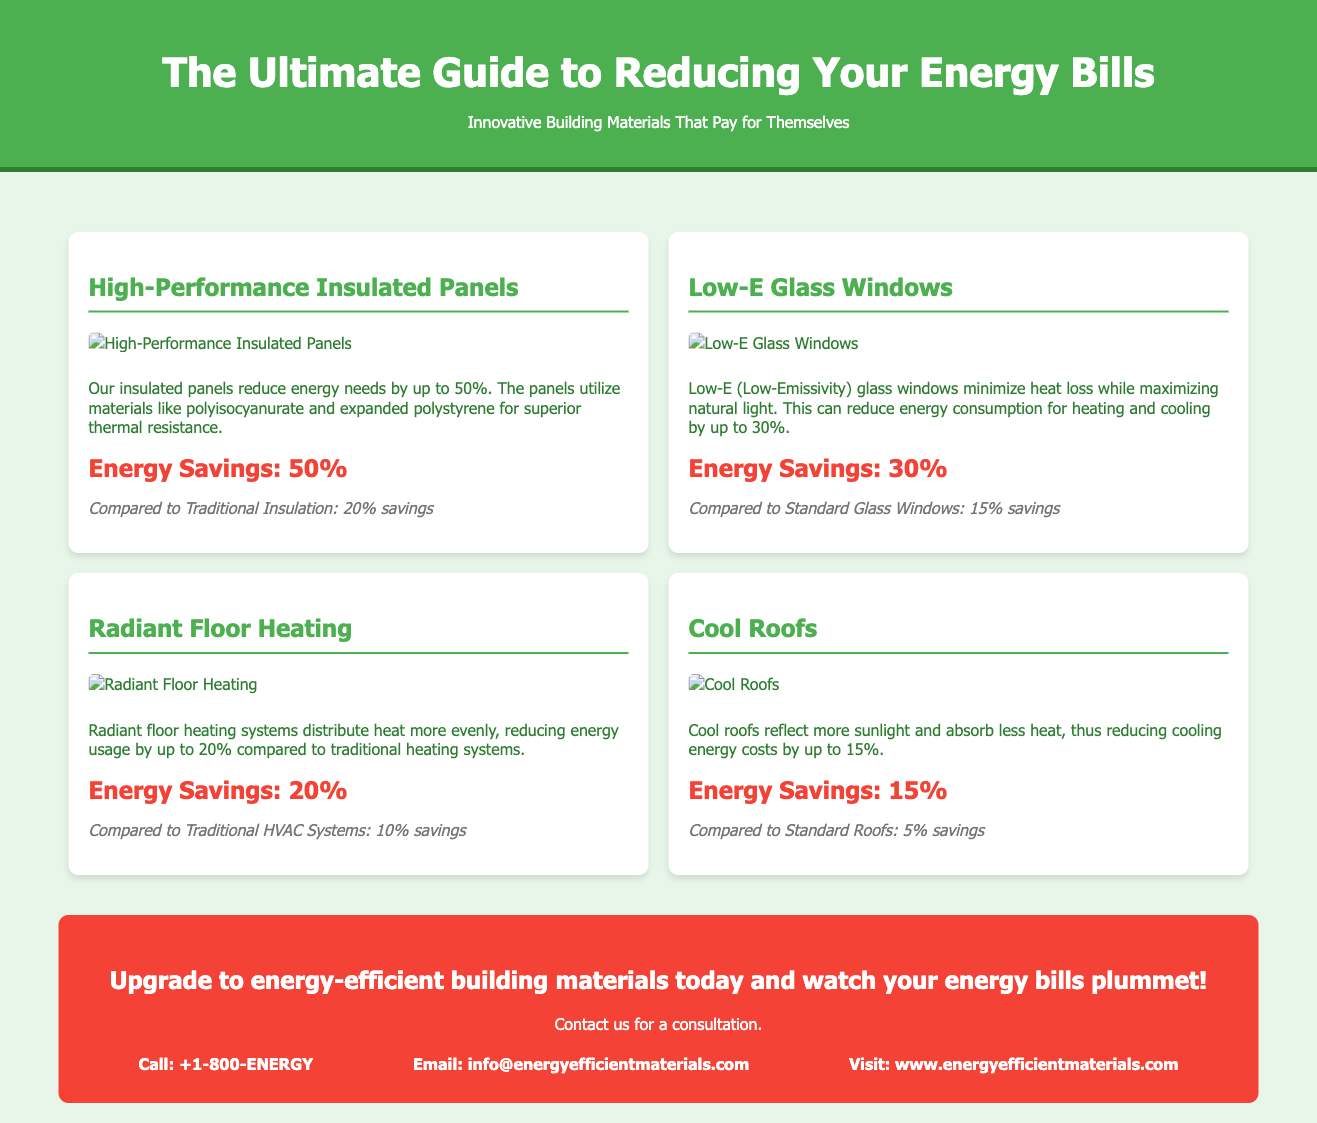What is the main title of the document? The main title is prominently displayed at the top of the document.
Answer: The Ultimate Guide to Reducing Your Energy Bills What percentage of energy savings do High-Performance Insulated Panels provide? The energy savings percentage is mentioned in the description of the panels.
Answer: 50% What type of windows can reduce energy consumption by up to 30%? The document specifies the type of windows that achieve this energy reduction.
Answer: Low-E Glass Windows Which energy-efficient feature offers 15% savings on cooling costs? The specific feature related to cooling costs is detailed in the infographic section.
Answer: Cool Roofs How does Radiant Floor Heating compare to traditional HVAC systems in energy savings? The comparison of energy savings is clear in the description of Radiant Floor Heating.
Answer: 10% savings What advice is provided in the call to action? The call to action encourages readers to take specific steps regarding energy efficiency.
Answer: Upgrade to energy-efficient building materials today What is the contact method for inquiries? The contact information for inquiries is included at the end of the document.
Answer: Email: info@energyefficientmaterials.com What is the color of the header section? The dominant color in the header section is defined in the styling of the document.
Answer: Green What image accompanies the cool roofs section? The document includes images to enhance the understanding of each section.
Answer: cool-roofs.png What is the main focus of the infographic display? The infographic displays specific performance metrics of various building materials.
Answer: Energy savings comparisons 